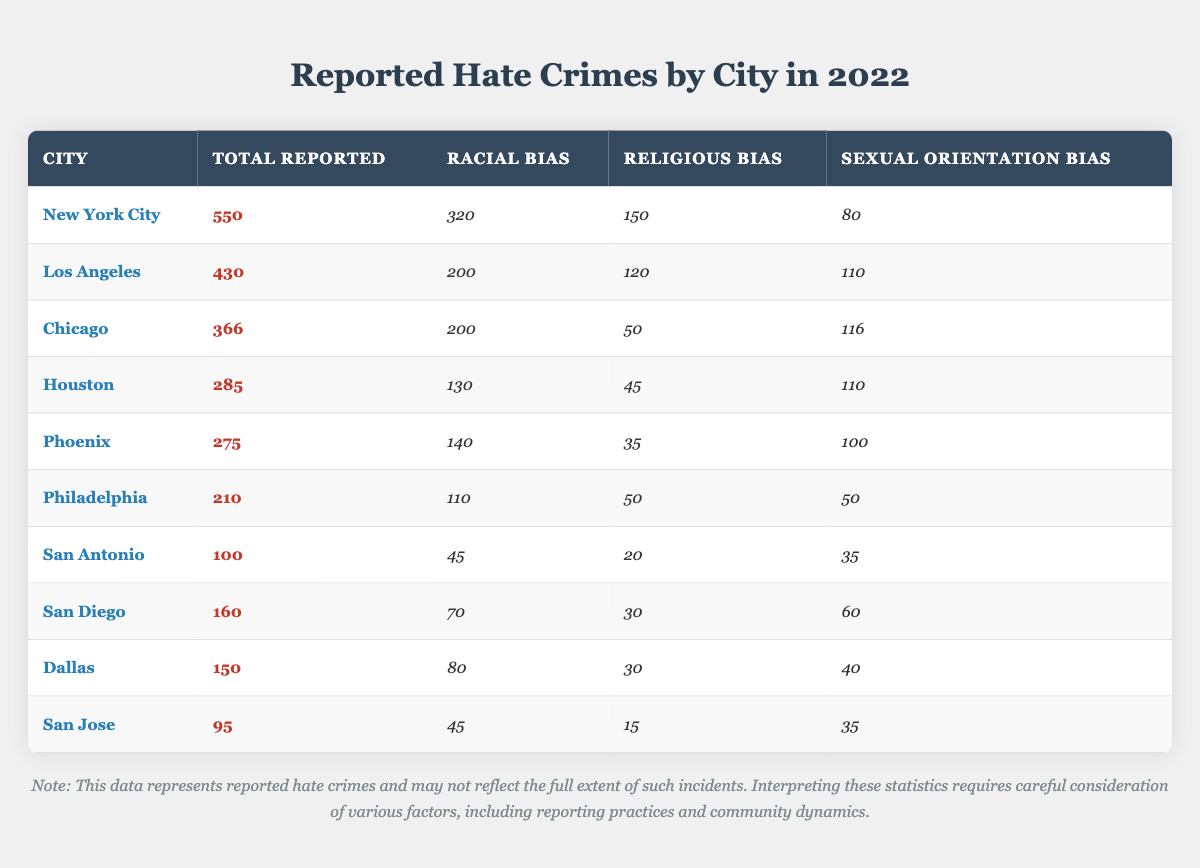What city reported the highest number of hate crimes in 2022? By examining the column for total reported hate crimes, New York City has the highest total at 550.
Answer: New York City How many hate crimes motivated by racial bias were reported in Chicago? Referring to the column for racial bias hate crimes, Chicago reported 200 hate crimes in this category.
Answer: 200 What is the total number of reported hate crimes for San Antonio and San Jose combined? Adding the total for San Antonio (100) and San Jose (95) gives a combined total of 100 + 95 = 195.
Answer: 195 Is it true that Los Angeles had more hate crimes related to sexual orientation than Philadelphia? Comparing the sexual orientation bias hate crimes, Los Angeles had 110 while Philadelphia had 50, thus Los Angeles did report more.
Answer: True Which city had the lowest total reported hate crimes, and what was the number? By checking the total reported column, San Jose had the lowest total with 95 reported hate crimes.
Answer: San Jose, 95 What percentage of total hate crimes in New York City were motivated by religious bias? Calculating the percentage: (150 religious bias / 550 total) * 100 = 27.27%.
Answer: 27.27% What is the difference between the total reported hate crimes in Houston and Phoenix? The total reported for Houston is 285, and for Phoenix, it is 275. The difference is 285 - 275 = 10.
Answer: 10 Which city has the same number of reported hate crimes for racial bias as Philadelphia's total? Philadelphia has 110 racial bias hate crimes. Checking the list, only Houston has 130, which is higher. Thus, none match the total for Philadelphia.
Answer: No city matches What is the average number of reported hate crimes across the listed cities? The total reported hate crimes across all cities is 2,386, and there are 10 cities, so 2,386 / 10 = 238.6.
Answer: 238.6 Which city has a higher number of hate crimes based on sexual orientation bias, Dallas or San Diego? Dallas reported 40 sexual orientation bias hate crimes, while San Diego reported 60. So, San Diego has more.
Answer: San Diego 